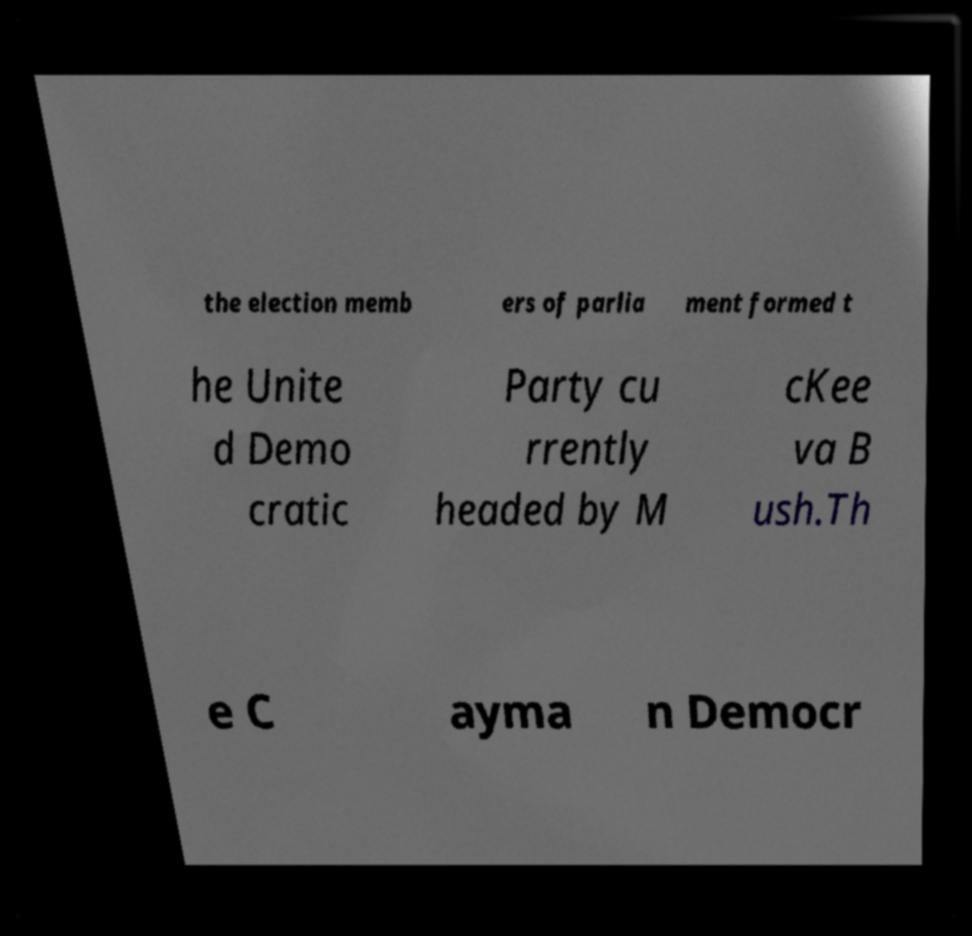Can you accurately transcribe the text from the provided image for me? the election memb ers of parlia ment formed t he Unite d Demo cratic Party cu rrently headed by M cKee va B ush.Th e C ayma n Democr 